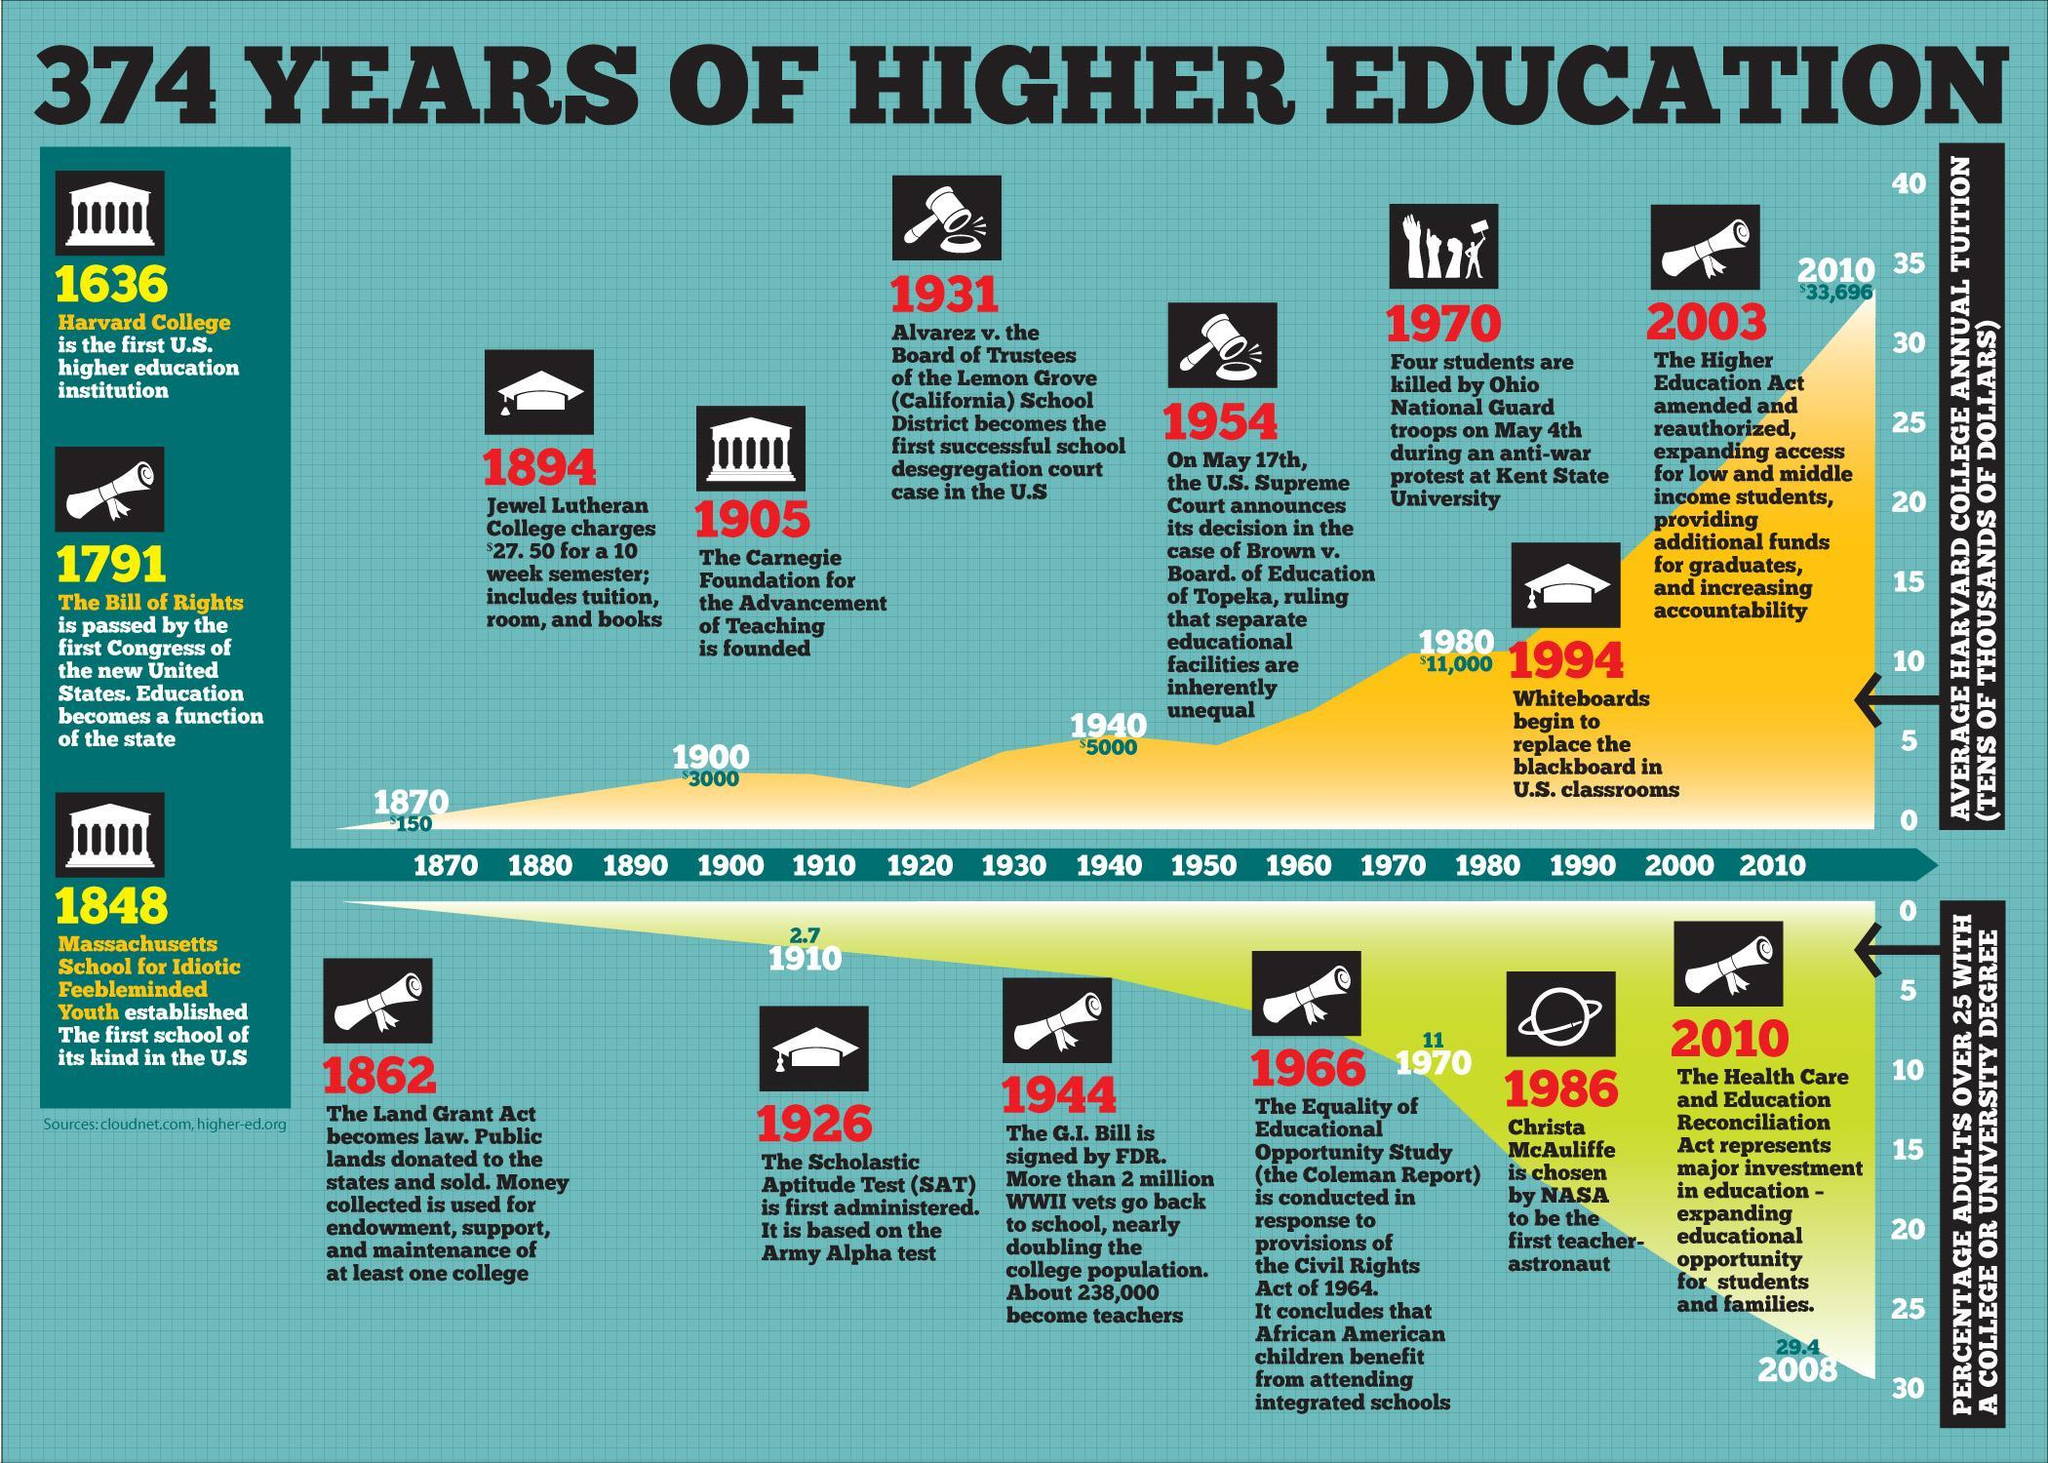What is the percentage of adults over 25 with a college or university degree in 2008?
Answer the question with a short phrase. 29.4 What is the percentage of adults over 25 with a college or university degree in 1910? 2.7 When was the first U.S. higher education institution started? 1636 When was the Carnegie Foundation for the advancement of teaching founded? 1905 What is the average Harvard college annual tuition (in tens of thousands of dollars) in 1980? $11,000 What is the average Harvard college annual tuition (in tens of thousands of dollars) in 1940? $5000 What is the average Harvard college annual tuition (in tens of thousands of dollars) in 2010? $33,696 In which year, whiteboards begin to replace the blackboard in U.S. classrooms? 1994 What is the percentage of adults over 25 with a college or university degree in 1970? 11 When was the first Scholastic Aptitude Test administrated? 1926 